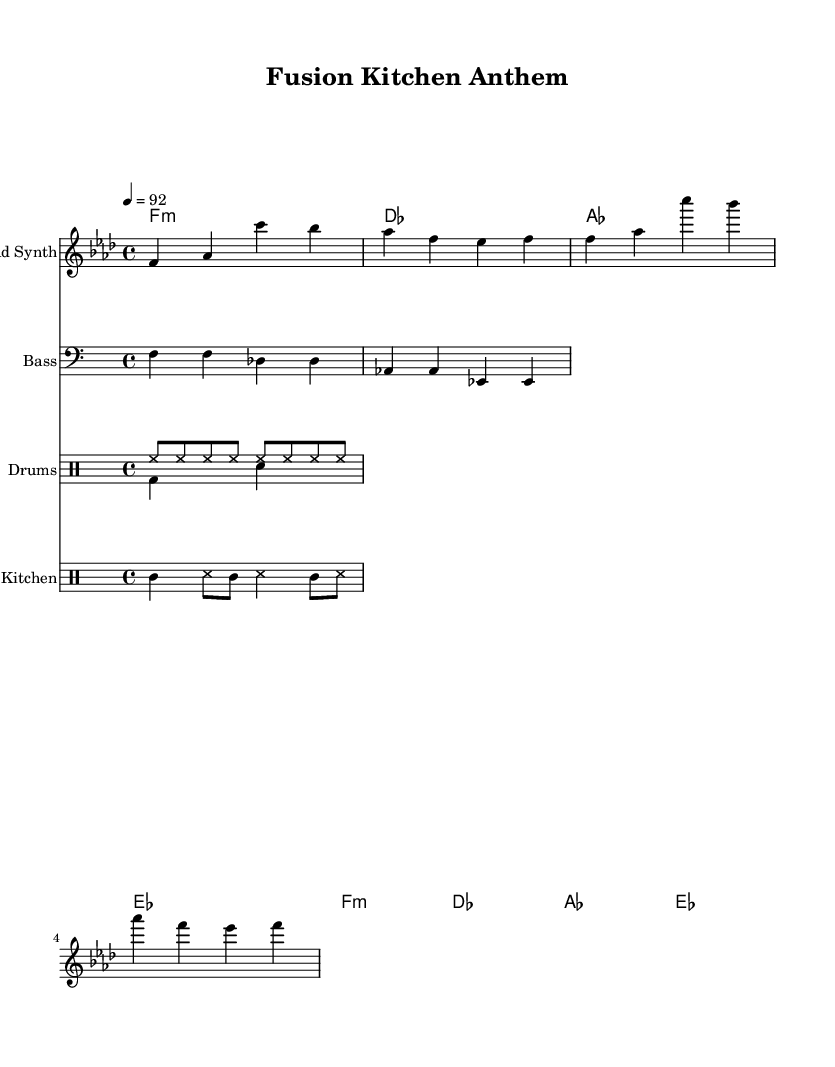What is the key signature of this music? The key signature is indicated by the two flat symbols (B♭ and E♭) found at the beginning of the staff. This identifies the piece as being in the key of F minor.
Answer: F minor What is the time signature of this music? The time signature is shown as a fraction at the beginning, indicating that there are four beats in each measure and the quarter note gets one beat. This is written as 4/4.
Answer: 4/4 What is the tempo of this music? The tempo marking appears at the beginning (4 = 92), which signifies that the piece should be played at a speed of 92 beats per minute.
Answer: 92 How many measures are in the melody? By counting the measures in the melody part of the music, it is clear that there are four measures indicated by the grouping of notes.
Answer: 4 Which instrument is labeled as "Lead Synth" in the score? The instrument labeled as "Lead Synth" is specified in the staff heading for the melody, indicating that this part should be played by a synthesizer instrument.
Answer: Lead Synth What type of drum patterns are used in this piece? The drum patterns consist of a combination of hi-hats, bass drums, and snare hits, which are typical in Hip Hop music. Specific notation like 'hh', 'bd', and 'sn' indicate these elements explicitly.
Answer: Hi-hat and bass drum What is the thematic connection between the lyrics and the music in terms of culinary innovation? The thematic connection represents the fusion of culinary styles reflected in the rhythmic and melodic structure of the piece, symbolizing creativity much like in street food.
Answer: Culinary fusion 